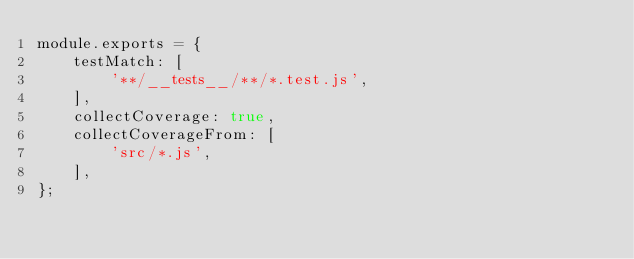<code> <loc_0><loc_0><loc_500><loc_500><_JavaScript_>module.exports = {
    testMatch: [
        '**/__tests__/**/*.test.js',
    ],
    collectCoverage: true,
    collectCoverageFrom: [
        'src/*.js',
    ],
};
</code> 